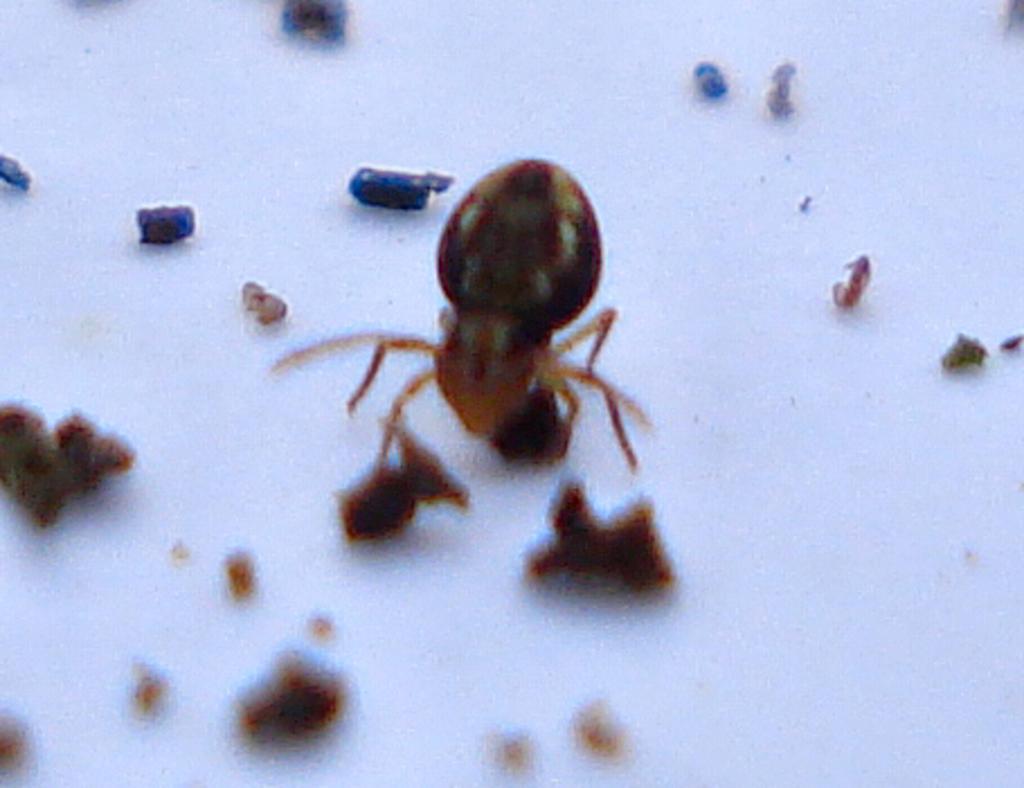Please provide a concise description of this image. In this image there is white color floor. There is a n ant. There are few food particles. 